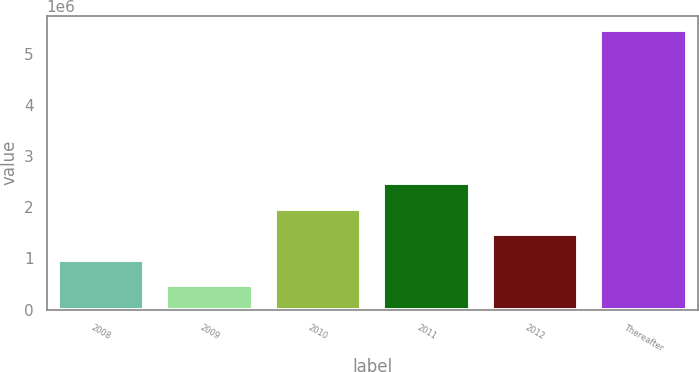<chart> <loc_0><loc_0><loc_500><loc_500><bar_chart><fcel>2008<fcel>2009<fcel>2010<fcel>2011<fcel>2012<fcel>Thereafter<nl><fcel>977816<fcel>478269<fcel>1.97691e+06<fcel>2.47646e+06<fcel>1.47736e+06<fcel>5.47373e+06<nl></chart> 